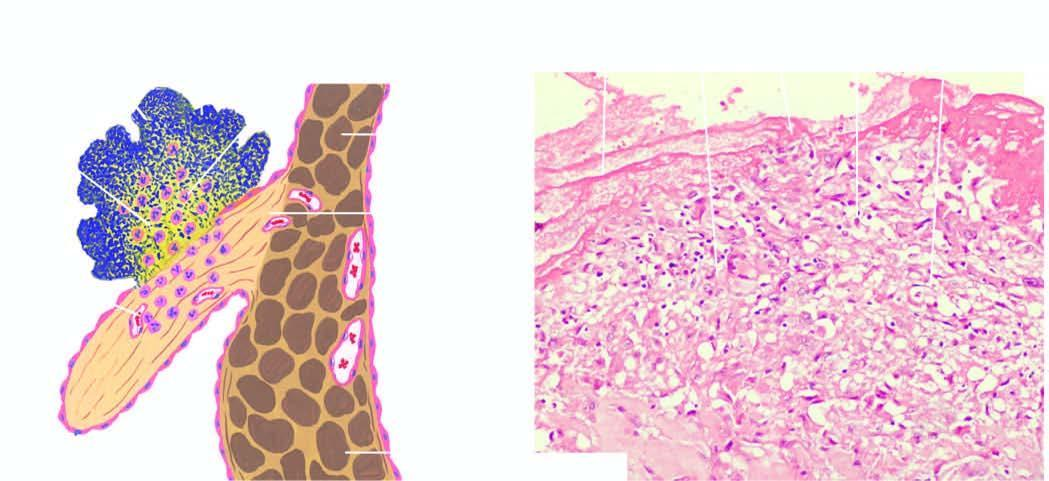does chematic representation of mechanisms show fibrin cap on luminal surface, layer of bacteria, and deeper zone of inflammatory cells, with prominence of neutrophils?
Answer the question using a single word or phrase. No 